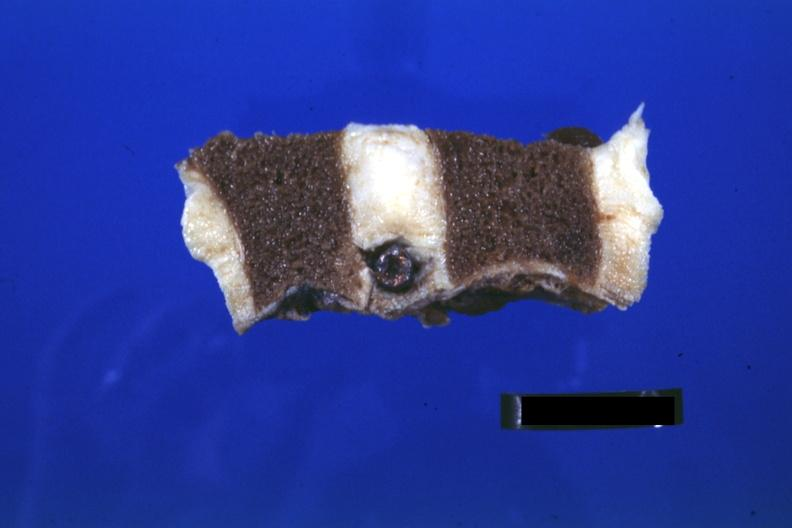does this image show probably natural color nice view of bullet in intervertebral disc t12-l1?
Answer the question using a single word or phrase. Yes 